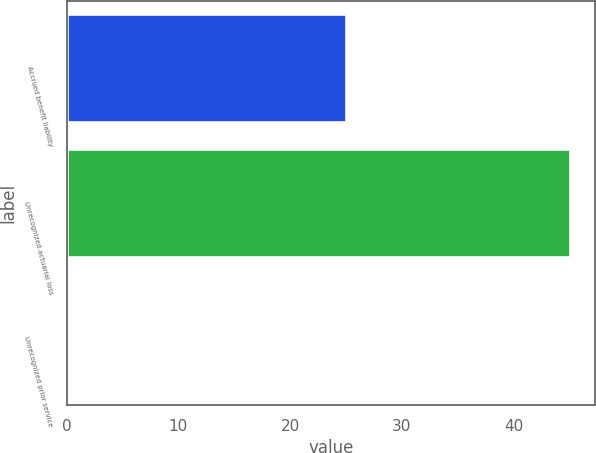Convert chart. <chart><loc_0><loc_0><loc_500><loc_500><bar_chart><fcel>Accrued benefit liability<fcel>Unrecognized actuarial loss<fcel>Unrecognized prior service<nl><fcel>25<fcel>45<fcel>0.13<nl></chart> 